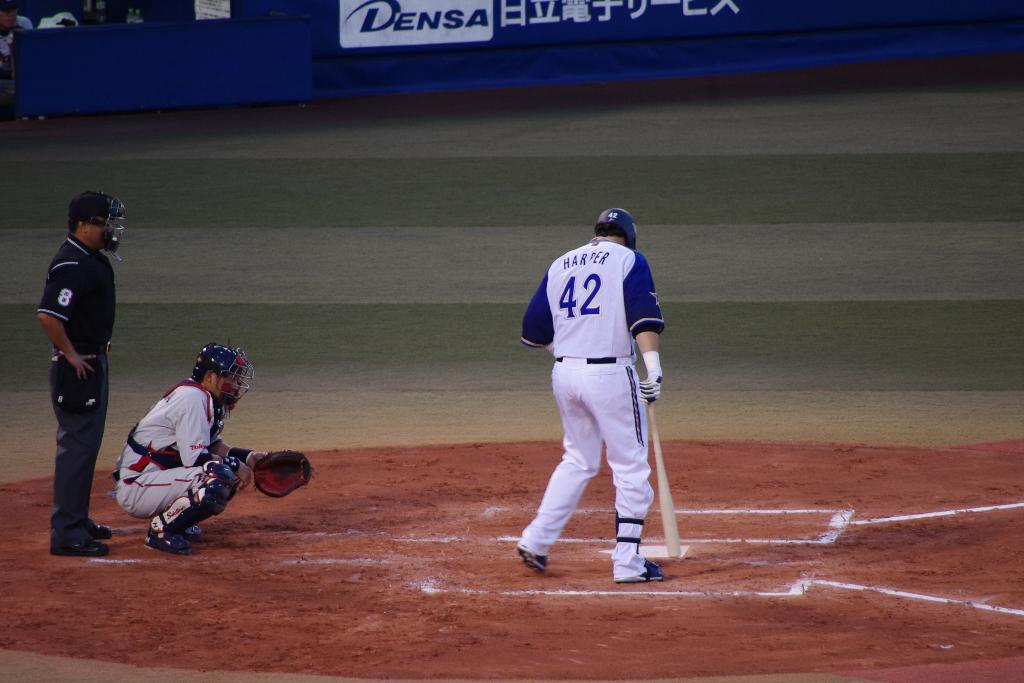What is the name of the player up to bat?
Offer a terse response. Harper. What number is on the player's jersey?
Give a very brief answer. 42. 